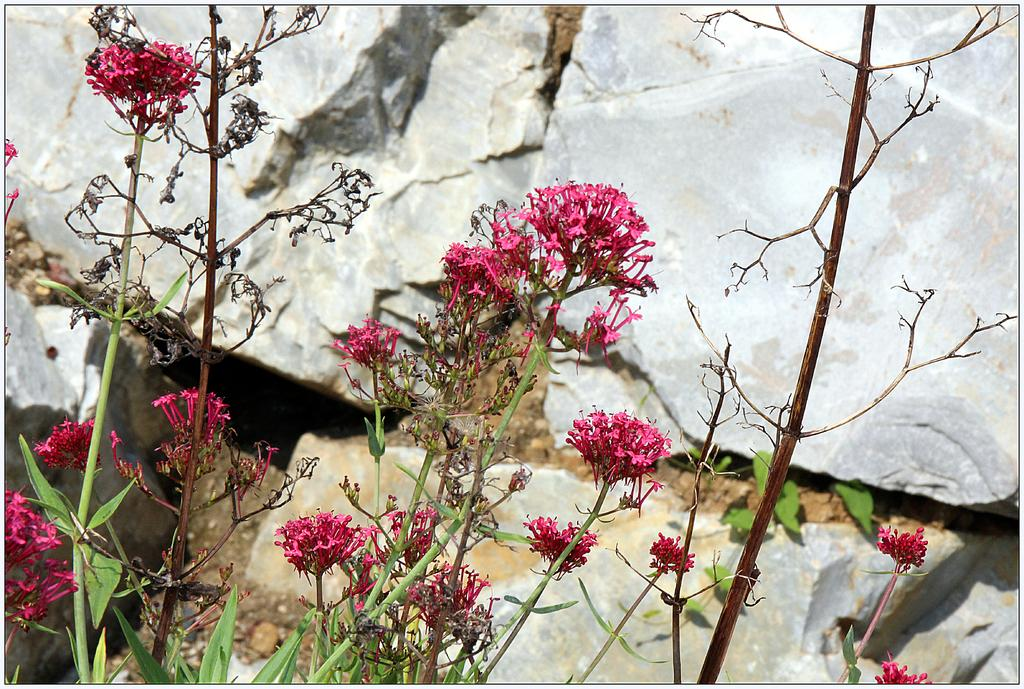What type of living organisms can be seen in the image? There are flowers and plants visible in the image. Are there any other natural elements present in the image? Yes, there are rocks in the image. What is the income of the man holding the snakes in the image? There is no man holding snakes present in the image. 